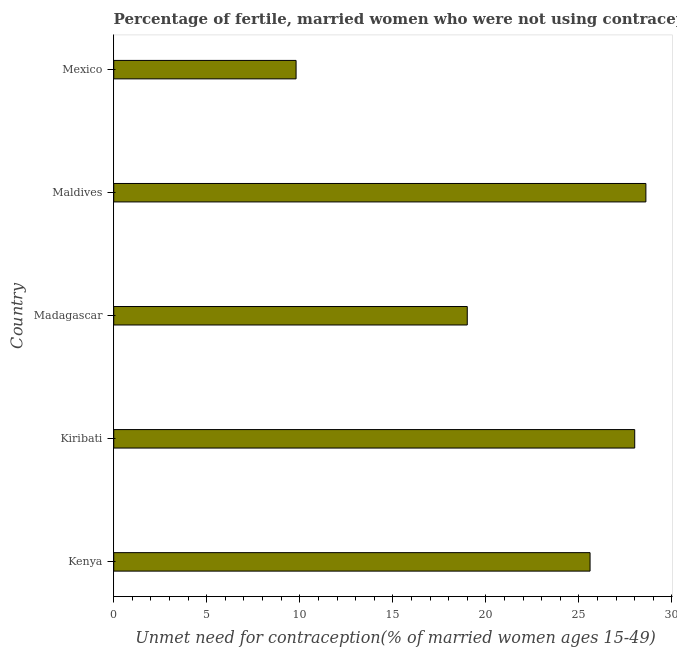What is the title of the graph?
Offer a very short reply. Percentage of fertile, married women who were not using contraception in 2009. What is the label or title of the X-axis?
Keep it short and to the point.  Unmet need for contraception(% of married women ages 15-49). What is the label or title of the Y-axis?
Your answer should be compact. Country. What is the number of married women who are not using contraception in Madagascar?
Your answer should be compact. 19. Across all countries, what is the maximum number of married women who are not using contraception?
Your answer should be compact. 28.6. Across all countries, what is the minimum number of married women who are not using contraception?
Keep it short and to the point. 9.8. In which country was the number of married women who are not using contraception maximum?
Provide a succinct answer. Maldives. In which country was the number of married women who are not using contraception minimum?
Offer a terse response. Mexico. What is the sum of the number of married women who are not using contraception?
Your answer should be compact. 111. What is the average number of married women who are not using contraception per country?
Your response must be concise. 22.2. What is the median number of married women who are not using contraception?
Make the answer very short. 25.6. In how many countries, is the number of married women who are not using contraception greater than 21 %?
Provide a succinct answer. 3. What is the ratio of the number of married women who are not using contraception in Madagascar to that in Mexico?
Ensure brevity in your answer.  1.94. Is the number of married women who are not using contraception in Kenya less than that in Kiribati?
Ensure brevity in your answer.  Yes. Is the difference between the number of married women who are not using contraception in Kiribati and Madagascar greater than the difference between any two countries?
Give a very brief answer. No. What is the difference between the highest and the second highest number of married women who are not using contraception?
Keep it short and to the point. 0.6. What is the difference between the highest and the lowest number of married women who are not using contraception?
Your answer should be compact. 18.8. How many bars are there?
Your response must be concise. 5. Are all the bars in the graph horizontal?
Your answer should be very brief. Yes. How many countries are there in the graph?
Keep it short and to the point. 5. Are the values on the major ticks of X-axis written in scientific E-notation?
Keep it short and to the point. No. What is the  Unmet need for contraception(% of married women ages 15-49) in Kenya?
Offer a terse response. 25.6. What is the  Unmet need for contraception(% of married women ages 15-49) in Kiribati?
Your answer should be very brief. 28. What is the  Unmet need for contraception(% of married women ages 15-49) in Madagascar?
Provide a short and direct response. 19. What is the  Unmet need for contraception(% of married women ages 15-49) in Maldives?
Make the answer very short. 28.6. What is the difference between the  Unmet need for contraception(% of married women ages 15-49) in Kenya and Madagascar?
Give a very brief answer. 6.6. What is the difference between the  Unmet need for contraception(% of married women ages 15-49) in Kenya and Maldives?
Your response must be concise. -3. What is the difference between the  Unmet need for contraception(% of married women ages 15-49) in Kenya and Mexico?
Your answer should be very brief. 15.8. What is the difference between the  Unmet need for contraception(% of married women ages 15-49) in Kiribati and Madagascar?
Your answer should be very brief. 9. What is the difference between the  Unmet need for contraception(% of married women ages 15-49) in Madagascar and Mexico?
Provide a succinct answer. 9.2. What is the difference between the  Unmet need for contraception(% of married women ages 15-49) in Maldives and Mexico?
Make the answer very short. 18.8. What is the ratio of the  Unmet need for contraception(% of married women ages 15-49) in Kenya to that in Kiribati?
Your answer should be very brief. 0.91. What is the ratio of the  Unmet need for contraception(% of married women ages 15-49) in Kenya to that in Madagascar?
Offer a very short reply. 1.35. What is the ratio of the  Unmet need for contraception(% of married women ages 15-49) in Kenya to that in Maldives?
Give a very brief answer. 0.9. What is the ratio of the  Unmet need for contraception(% of married women ages 15-49) in Kenya to that in Mexico?
Make the answer very short. 2.61. What is the ratio of the  Unmet need for contraception(% of married women ages 15-49) in Kiribati to that in Madagascar?
Your answer should be very brief. 1.47. What is the ratio of the  Unmet need for contraception(% of married women ages 15-49) in Kiribati to that in Maldives?
Your answer should be very brief. 0.98. What is the ratio of the  Unmet need for contraception(% of married women ages 15-49) in Kiribati to that in Mexico?
Your response must be concise. 2.86. What is the ratio of the  Unmet need for contraception(% of married women ages 15-49) in Madagascar to that in Maldives?
Provide a short and direct response. 0.66. What is the ratio of the  Unmet need for contraception(% of married women ages 15-49) in Madagascar to that in Mexico?
Provide a short and direct response. 1.94. What is the ratio of the  Unmet need for contraception(% of married women ages 15-49) in Maldives to that in Mexico?
Give a very brief answer. 2.92. 